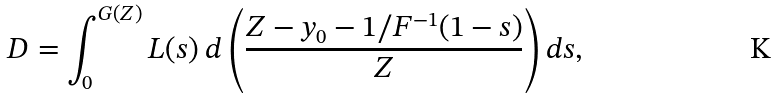Convert formula to latex. <formula><loc_0><loc_0><loc_500><loc_500>D = \int _ { 0 } ^ { G ( Z ) } L ( s ) \text { } d \left ( \frac { Z - y _ { 0 } - 1 / F ^ { - 1 } ( 1 - s ) } { Z } \right ) d s ,</formula> 